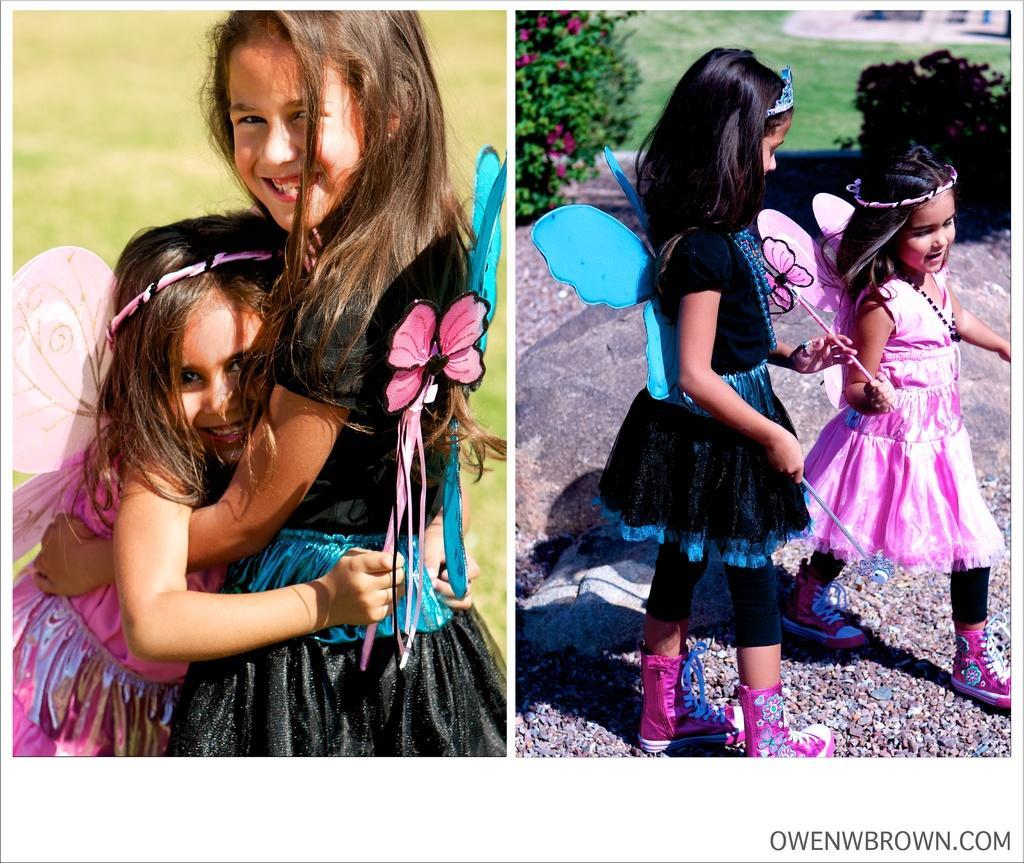Describe this image in one or two sentences. As we can see in the image there is grass, plants and two people standing. 